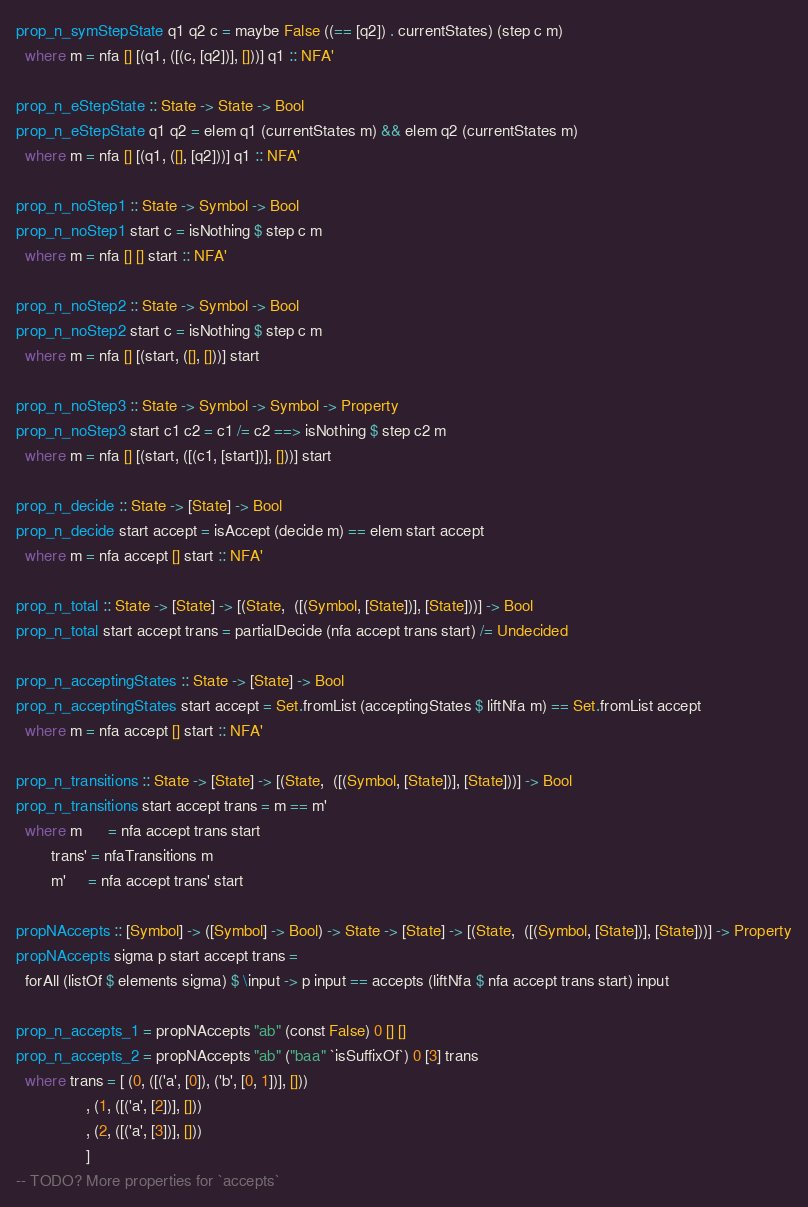<code> <loc_0><loc_0><loc_500><loc_500><_Haskell_>prop_n_symStepState q1 q2 c = maybe False ((== [q2]) . currentStates) (step c m)
  where m = nfa [] [(q1, ([(c, [q2])], []))] q1 :: NFA'

prop_n_eStepState :: State -> State -> Bool
prop_n_eStepState q1 q2 = elem q1 (currentStates m) && elem q2 (currentStates m)
  where m = nfa [] [(q1, ([], [q2]))] q1 :: NFA'

prop_n_noStep1 :: State -> Symbol -> Bool
prop_n_noStep1 start c = isNothing $ step c m
  where m = nfa [] [] start :: NFA'

prop_n_noStep2 :: State -> Symbol -> Bool
prop_n_noStep2 start c = isNothing $ step c m
  where m = nfa [] [(start, ([], []))] start

prop_n_noStep3 :: State -> Symbol -> Symbol -> Property
prop_n_noStep3 start c1 c2 = c1 /= c2 ==> isNothing $ step c2 m
  where m = nfa [] [(start, ([(c1, [start])], []))] start

prop_n_decide :: State -> [State] -> Bool
prop_n_decide start accept = isAccept (decide m) == elem start accept
  where m = nfa accept [] start :: NFA'

prop_n_total :: State -> [State] -> [(State,  ([(Symbol, [State])], [State]))] -> Bool
prop_n_total start accept trans = partialDecide (nfa accept trans start) /= Undecided

prop_n_acceptingStates :: State -> [State] -> Bool
prop_n_acceptingStates start accept = Set.fromList (acceptingStates $ liftNfa m) == Set.fromList accept
  where m = nfa accept [] start :: NFA'

prop_n_transitions :: State -> [State] -> [(State,  ([(Symbol, [State])], [State]))] -> Bool
prop_n_transitions start accept trans = m == m'
  where m      = nfa accept trans start
        trans' = nfaTransitions m
        m'     = nfa accept trans' start

propNAccepts :: [Symbol] -> ([Symbol] -> Bool) -> State -> [State] -> [(State,  ([(Symbol, [State])], [State]))] -> Property
propNAccepts sigma p start accept trans =
  forAll (listOf $ elements sigma) $ \input -> p input == accepts (liftNfa $ nfa accept trans start) input

prop_n_accepts_1 = propNAccepts "ab" (const False) 0 [] []
prop_n_accepts_2 = propNAccepts "ab" ("baa" `isSuffixOf`) 0 [3] trans
  where trans = [ (0, ([('a', [0]), ('b', [0, 1])], []))
                , (1, ([('a', [2])], []))
                , (2, ([('a', [3])], []))
                ]
-- TODO? More properties for `accepts`
</code> 